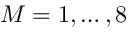Convert formula to latex. <formula><loc_0><loc_0><loc_500><loc_500>M = 1 , \dots , 8</formula> 